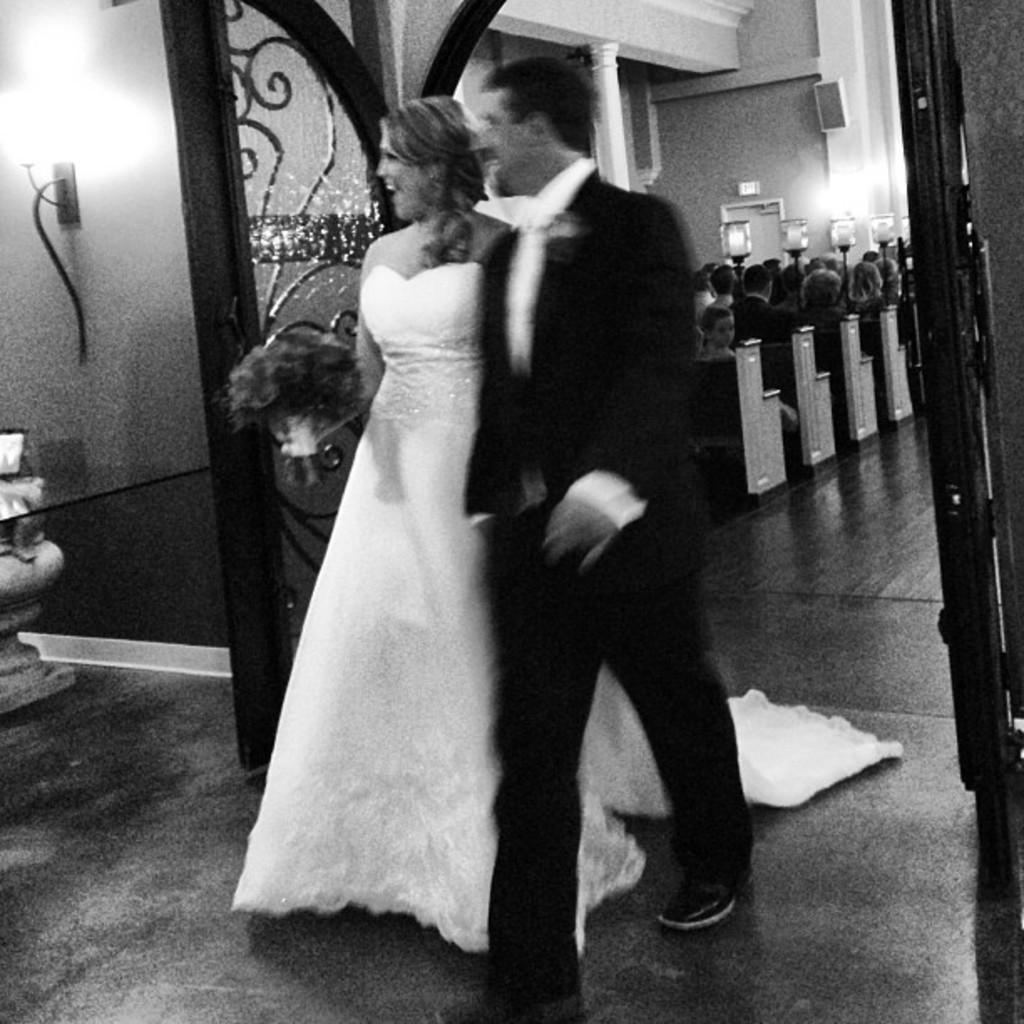Could you give a brief overview of what you see in this image? In this black and white image there is a couple walking from the entrance, there is like a pot, behind that there is a lamp on the wall and there are open doors, from the entrance we can see there are a few people sitting on the benches, there are a few lamps and there is an object hanging on the wall and there is a door. 